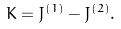<formula> <loc_0><loc_0><loc_500><loc_500>K = J ^ { ( 1 ) } - J ^ { ( 2 ) } .</formula> 